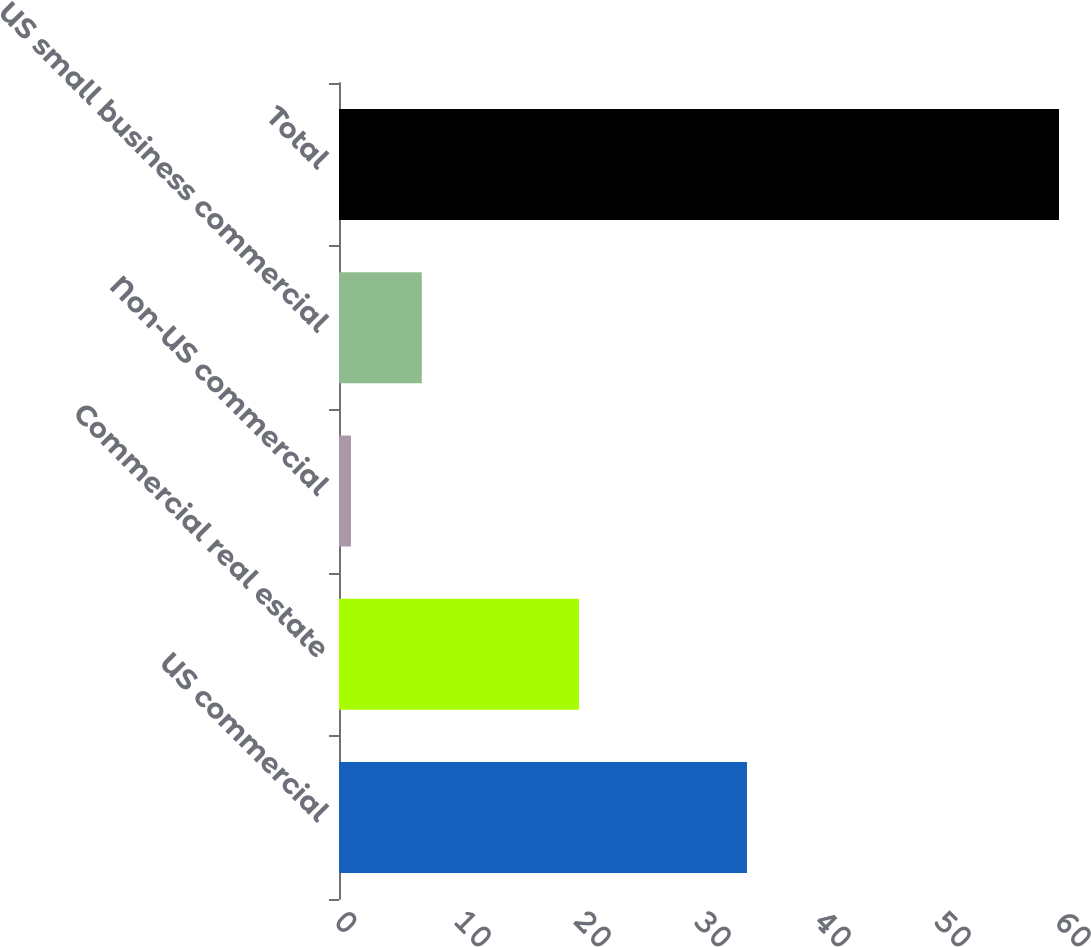Convert chart to OTSL. <chart><loc_0><loc_0><loc_500><loc_500><bar_chart><fcel>US commercial<fcel>Commercial real estate<fcel>Non-US commercial<fcel>US small business commercial<fcel>Total<nl><fcel>34<fcel>20<fcel>1<fcel>6.9<fcel>60<nl></chart> 